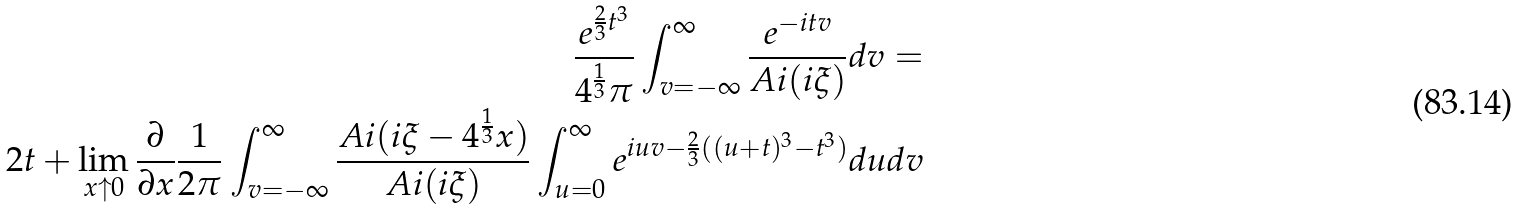<formula> <loc_0><loc_0><loc_500><loc_500>\frac { e ^ { \frac { 2 } { 3 } t ^ { 3 } } } { 4 ^ { \frac { 1 } { 3 } } \pi } \int _ { v = - \infty } ^ { \infty } \frac { e ^ { - i t v } } { A i ( i \xi ) } d v = \\ 2 t + \lim _ { x \uparrow 0 } \frac { \partial } { \partial x } \frac { 1 } { 2 \pi } \int _ { v = - \infty } ^ { \infty } \frac { A i ( i \xi - 4 ^ { \frac { 1 } { 3 } } x ) } { A i ( i \xi ) } \int _ { u = 0 } ^ { \infty } e ^ { i u v - \frac { 2 } { 3 } ( ( u + t ) ^ { 3 } - t ^ { 3 } ) } d u d v</formula> 